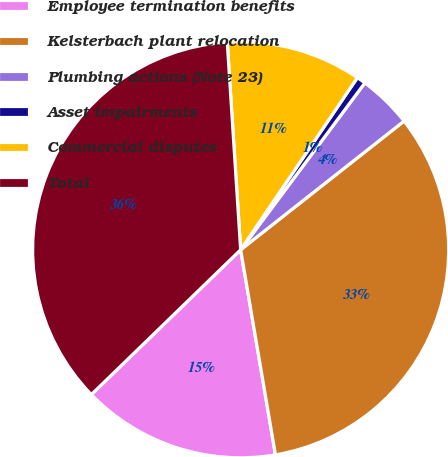Convert chart to OTSL. <chart><loc_0><loc_0><loc_500><loc_500><pie_chart><fcel>Employee termination benefits<fcel>Kelsterbach plant relocation<fcel>Plumbing actions (Note 23)<fcel>Asset impairments<fcel>Commercial disputes<fcel>Total<nl><fcel>15.42%<fcel>32.94%<fcel>4.2%<fcel>0.7%<fcel>10.51%<fcel>36.23%<nl></chart> 